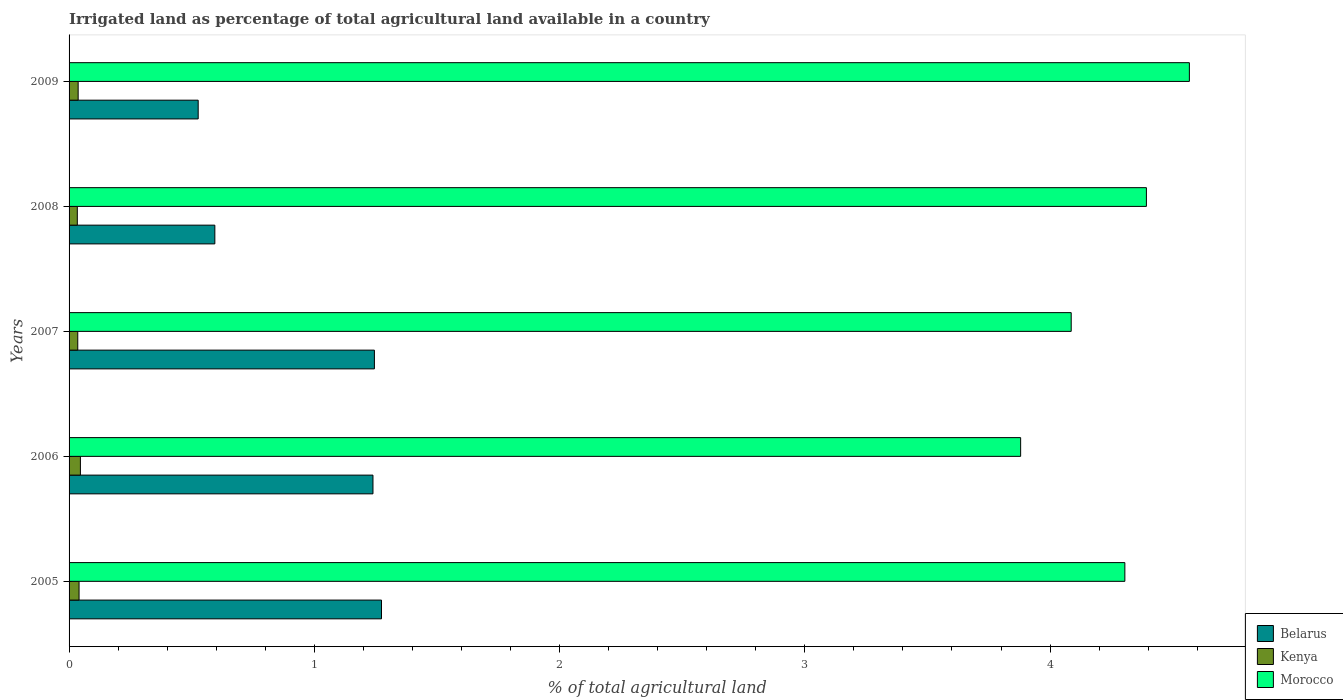How many different coloured bars are there?
Your answer should be compact. 3. How many groups of bars are there?
Make the answer very short. 5. Are the number of bars on each tick of the Y-axis equal?
Give a very brief answer. Yes. What is the percentage of irrigated land in Belarus in 2007?
Give a very brief answer. 1.24. Across all years, what is the maximum percentage of irrigated land in Kenya?
Your answer should be compact. 0.05. Across all years, what is the minimum percentage of irrigated land in Kenya?
Your answer should be very brief. 0.03. In which year was the percentage of irrigated land in Morocco maximum?
Make the answer very short. 2009. What is the total percentage of irrigated land in Kenya in the graph?
Offer a very short reply. 0.19. What is the difference between the percentage of irrigated land in Kenya in 2005 and that in 2006?
Provide a short and direct response. -0.01. What is the difference between the percentage of irrigated land in Belarus in 2005 and the percentage of irrigated land in Kenya in 2008?
Ensure brevity in your answer.  1.24. What is the average percentage of irrigated land in Kenya per year?
Provide a short and direct response. 0.04. In the year 2005, what is the difference between the percentage of irrigated land in Kenya and percentage of irrigated land in Morocco?
Offer a very short reply. -4.26. What is the ratio of the percentage of irrigated land in Belarus in 2007 to that in 2009?
Offer a very short reply. 2.36. Is the difference between the percentage of irrigated land in Kenya in 2005 and 2007 greater than the difference between the percentage of irrigated land in Morocco in 2005 and 2007?
Make the answer very short. No. What is the difference between the highest and the second highest percentage of irrigated land in Morocco?
Provide a succinct answer. 0.18. What is the difference between the highest and the lowest percentage of irrigated land in Belarus?
Give a very brief answer. 0.75. In how many years, is the percentage of irrigated land in Kenya greater than the average percentage of irrigated land in Kenya taken over all years?
Keep it short and to the point. 2. What does the 1st bar from the top in 2007 represents?
Ensure brevity in your answer.  Morocco. What does the 2nd bar from the bottom in 2008 represents?
Your response must be concise. Kenya. How many years are there in the graph?
Make the answer very short. 5. Does the graph contain any zero values?
Ensure brevity in your answer.  No. Does the graph contain grids?
Ensure brevity in your answer.  No. What is the title of the graph?
Offer a very short reply. Irrigated land as percentage of total agricultural land available in a country. Does "Mauritius" appear as one of the legend labels in the graph?
Offer a terse response. No. What is the label or title of the X-axis?
Give a very brief answer. % of total agricultural land. What is the % of total agricultural land of Belarus in 2005?
Provide a succinct answer. 1.27. What is the % of total agricultural land of Kenya in 2005?
Your answer should be very brief. 0.04. What is the % of total agricultural land in Morocco in 2005?
Keep it short and to the point. 4.3. What is the % of total agricultural land in Belarus in 2006?
Provide a succinct answer. 1.24. What is the % of total agricultural land in Kenya in 2006?
Offer a terse response. 0.05. What is the % of total agricultural land of Morocco in 2006?
Make the answer very short. 3.88. What is the % of total agricultural land in Belarus in 2007?
Provide a succinct answer. 1.24. What is the % of total agricultural land of Kenya in 2007?
Your answer should be compact. 0.04. What is the % of total agricultural land of Morocco in 2007?
Ensure brevity in your answer.  4.09. What is the % of total agricultural land of Belarus in 2008?
Provide a short and direct response. 0.59. What is the % of total agricultural land in Kenya in 2008?
Offer a very short reply. 0.03. What is the % of total agricultural land of Morocco in 2008?
Your response must be concise. 4.39. What is the % of total agricultural land of Belarus in 2009?
Make the answer very short. 0.53. What is the % of total agricultural land in Kenya in 2009?
Offer a very short reply. 0.04. What is the % of total agricultural land of Morocco in 2009?
Keep it short and to the point. 4.57. Across all years, what is the maximum % of total agricultural land in Belarus?
Your response must be concise. 1.27. Across all years, what is the maximum % of total agricultural land of Kenya?
Keep it short and to the point. 0.05. Across all years, what is the maximum % of total agricultural land in Morocco?
Keep it short and to the point. 4.57. Across all years, what is the minimum % of total agricultural land in Belarus?
Provide a succinct answer. 0.53. Across all years, what is the minimum % of total agricultural land in Kenya?
Your answer should be compact. 0.03. Across all years, what is the minimum % of total agricultural land in Morocco?
Provide a succinct answer. 3.88. What is the total % of total agricultural land of Belarus in the graph?
Ensure brevity in your answer.  4.88. What is the total % of total agricultural land in Kenya in the graph?
Provide a short and direct response. 0.19. What is the total % of total agricultural land in Morocco in the graph?
Your response must be concise. 21.23. What is the difference between the % of total agricultural land of Belarus in 2005 and that in 2006?
Your answer should be compact. 0.03. What is the difference between the % of total agricultural land of Kenya in 2005 and that in 2006?
Give a very brief answer. -0.01. What is the difference between the % of total agricultural land of Morocco in 2005 and that in 2006?
Your answer should be compact. 0.42. What is the difference between the % of total agricultural land of Belarus in 2005 and that in 2007?
Keep it short and to the point. 0.03. What is the difference between the % of total agricultural land of Kenya in 2005 and that in 2007?
Ensure brevity in your answer.  0.01. What is the difference between the % of total agricultural land of Morocco in 2005 and that in 2007?
Keep it short and to the point. 0.22. What is the difference between the % of total agricultural land of Belarus in 2005 and that in 2008?
Offer a very short reply. 0.68. What is the difference between the % of total agricultural land of Kenya in 2005 and that in 2008?
Your answer should be compact. 0.01. What is the difference between the % of total agricultural land of Morocco in 2005 and that in 2008?
Give a very brief answer. -0.09. What is the difference between the % of total agricultural land of Belarus in 2005 and that in 2009?
Ensure brevity in your answer.  0.75. What is the difference between the % of total agricultural land of Kenya in 2005 and that in 2009?
Give a very brief answer. 0. What is the difference between the % of total agricultural land in Morocco in 2005 and that in 2009?
Ensure brevity in your answer.  -0.26. What is the difference between the % of total agricultural land of Belarus in 2006 and that in 2007?
Give a very brief answer. -0.01. What is the difference between the % of total agricultural land in Kenya in 2006 and that in 2007?
Offer a very short reply. 0.01. What is the difference between the % of total agricultural land in Morocco in 2006 and that in 2007?
Your answer should be compact. -0.21. What is the difference between the % of total agricultural land in Belarus in 2006 and that in 2008?
Your answer should be very brief. 0.64. What is the difference between the % of total agricultural land of Kenya in 2006 and that in 2008?
Ensure brevity in your answer.  0.01. What is the difference between the % of total agricultural land in Morocco in 2006 and that in 2008?
Give a very brief answer. -0.51. What is the difference between the % of total agricultural land in Belarus in 2006 and that in 2009?
Keep it short and to the point. 0.71. What is the difference between the % of total agricultural land in Kenya in 2006 and that in 2009?
Your response must be concise. 0.01. What is the difference between the % of total agricultural land of Morocco in 2006 and that in 2009?
Provide a succinct answer. -0.69. What is the difference between the % of total agricultural land in Belarus in 2007 and that in 2008?
Make the answer very short. 0.65. What is the difference between the % of total agricultural land in Kenya in 2007 and that in 2008?
Keep it short and to the point. 0. What is the difference between the % of total agricultural land of Morocco in 2007 and that in 2008?
Give a very brief answer. -0.31. What is the difference between the % of total agricultural land in Belarus in 2007 and that in 2009?
Make the answer very short. 0.72. What is the difference between the % of total agricultural land of Kenya in 2007 and that in 2009?
Your answer should be compact. -0. What is the difference between the % of total agricultural land in Morocco in 2007 and that in 2009?
Provide a succinct answer. -0.48. What is the difference between the % of total agricultural land in Belarus in 2008 and that in 2009?
Ensure brevity in your answer.  0.07. What is the difference between the % of total agricultural land of Kenya in 2008 and that in 2009?
Keep it short and to the point. -0. What is the difference between the % of total agricultural land in Morocco in 2008 and that in 2009?
Your answer should be compact. -0.18. What is the difference between the % of total agricultural land in Belarus in 2005 and the % of total agricultural land in Kenya in 2006?
Offer a terse response. 1.23. What is the difference between the % of total agricultural land in Belarus in 2005 and the % of total agricultural land in Morocco in 2006?
Your response must be concise. -2.61. What is the difference between the % of total agricultural land of Kenya in 2005 and the % of total agricultural land of Morocco in 2006?
Offer a very short reply. -3.84. What is the difference between the % of total agricultural land in Belarus in 2005 and the % of total agricultural land in Kenya in 2007?
Provide a short and direct response. 1.24. What is the difference between the % of total agricultural land of Belarus in 2005 and the % of total agricultural land of Morocco in 2007?
Keep it short and to the point. -2.81. What is the difference between the % of total agricultural land of Kenya in 2005 and the % of total agricultural land of Morocco in 2007?
Your response must be concise. -4.05. What is the difference between the % of total agricultural land of Belarus in 2005 and the % of total agricultural land of Kenya in 2008?
Ensure brevity in your answer.  1.24. What is the difference between the % of total agricultural land of Belarus in 2005 and the % of total agricultural land of Morocco in 2008?
Provide a short and direct response. -3.12. What is the difference between the % of total agricultural land in Kenya in 2005 and the % of total agricultural land in Morocco in 2008?
Ensure brevity in your answer.  -4.35. What is the difference between the % of total agricultural land in Belarus in 2005 and the % of total agricultural land in Kenya in 2009?
Provide a short and direct response. 1.24. What is the difference between the % of total agricultural land in Belarus in 2005 and the % of total agricultural land in Morocco in 2009?
Your answer should be very brief. -3.29. What is the difference between the % of total agricultural land in Kenya in 2005 and the % of total agricultural land in Morocco in 2009?
Provide a succinct answer. -4.53. What is the difference between the % of total agricultural land in Belarus in 2006 and the % of total agricultural land in Kenya in 2007?
Your answer should be compact. 1.2. What is the difference between the % of total agricultural land of Belarus in 2006 and the % of total agricultural land of Morocco in 2007?
Your answer should be compact. -2.85. What is the difference between the % of total agricultural land in Kenya in 2006 and the % of total agricultural land in Morocco in 2007?
Make the answer very short. -4.04. What is the difference between the % of total agricultural land of Belarus in 2006 and the % of total agricultural land of Kenya in 2008?
Your answer should be compact. 1.21. What is the difference between the % of total agricultural land in Belarus in 2006 and the % of total agricultural land in Morocco in 2008?
Offer a very short reply. -3.15. What is the difference between the % of total agricultural land in Kenya in 2006 and the % of total agricultural land in Morocco in 2008?
Your answer should be very brief. -4.35. What is the difference between the % of total agricultural land in Belarus in 2006 and the % of total agricultural land in Kenya in 2009?
Your answer should be very brief. 1.2. What is the difference between the % of total agricultural land of Belarus in 2006 and the % of total agricultural land of Morocco in 2009?
Ensure brevity in your answer.  -3.33. What is the difference between the % of total agricultural land of Kenya in 2006 and the % of total agricultural land of Morocco in 2009?
Provide a succinct answer. -4.52. What is the difference between the % of total agricultural land in Belarus in 2007 and the % of total agricultural land in Kenya in 2008?
Your answer should be very brief. 1.21. What is the difference between the % of total agricultural land in Belarus in 2007 and the % of total agricultural land in Morocco in 2008?
Give a very brief answer. -3.15. What is the difference between the % of total agricultural land of Kenya in 2007 and the % of total agricultural land of Morocco in 2008?
Your response must be concise. -4.36. What is the difference between the % of total agricultural land of Belarus in 2007 and the % of total agricultural land of Kenya in 2009?
Provide a succinct answer. 1.21. What is the difference between the % of total agricultural land of Belarus in 2007 and the % of total agricultural land of Morocco in 2009?
Provide a succinct answer. -3.32. What is the difference between the % of total agricultural land of Kenya in 2007 and the % of total agricultural land of Morocco in 2009?
Provide a short and direct response. -4.53. What is the difference between the % of total agricultural land in Belarus in 2008 and the % of total agricultural land in Kenya in 2009?
Ensure brevity in your answer.  0.56. What is the difference between the % of total agricultural land of Belarus in 2008 and the % of total agricultural land of Morocco in 2009?
Keep it short and to the point. -3.97. What is the difference between the % of total agricultural land of Kenya in 2008 and the % of total agricultural land of Morocco in 2009?
Ensure brevity in your answer.  -4.53. What is the average % of total agricultural land of Belarus per year?
Give a very brief answer. 0.98. What is the average % of total agricultural land in Kenya per year?
Keep it short and to the point. 0.04. What is the average % of total agricultural land in Morocco per year?
Offer a terse response. 4.25. In the year 2005, what is the difference between the % of total agricultural land in Belarus and % of total agricultural land in Kenya?
Provide a short and direct response. 1.23. In the year 2005, what is the difference between the % of total agricultural land in Belarus and % of total agricultural land in Morocco?
Keep it short and to the point. -3.03. In the year 2005, what is the difference between the % of total agricultural land in Kenya and % of total agricultural land in Morocco?
Your answer should be very brief. -4.26. In the year 2006, what is the difference between the % of total agricultural land in Belarus and % of total agricultural land in Kenya?
Provide a succinct answer. 1.19. In the year 2006, what is the difference between the % of total agricultural land of Belarus and % of total agricultural land of Morocco?
Your response must be concise. -2.64. In the year 2006, what is the difference between the % of total agricultural land of Kenya and % of total agricultural land of Morocco?
Provide a succinct answer. -3.83. In the year 2007, what is the difference between the % of total agricultural land of Belarus and % of total agricultural land of Kenya?
Offer a terse response. 1.21. In the year 2007, what is the difference between the % of total agricultural land in Belarus and % of total agricultural land in Morocco?
Give a very brief answer. -2.84. In the year 2007, what is the difference between the % of total agricultural land in Kenya and % of total agricultural land in Morocco?
Make the answer very short. -4.05. In the year 2008, what is the difference between the % of total agricultural land in Belarus and % of total agricultural land in Kenya?
Give a very brief answer. 0.56. In the year 2008, what is the difference between the % of total agricultural land of Belarus and % of total agricultural land of Morocco?
Offer a very short reply. -3.8. In the year 2008, what is the difference between the % of total agricultural land of Kenya and % of total agricultural land of Morocco?
Offer a terse response. -4.36. In the year 2009, what is the difference between the % of total agricultural land of Belarus and % of total agricultural land of Kenya?
Make the answer very short. 0.49. In the year 2009, what is the difference between the % of total agricultural land of Belarus and % of total agricultural land of Morocco?
Provide a short and direct response. -4.04. In the year 2009, what is the difference between the % of total agricultural land in Kenya and % of total agricultural land in Morocco?
Your answer should be compact. -4.53. What is the ratio of the % of total agricultural land of Belarus in 2005 to that in 2006?
Your answer should be compact. 1.03. What is the ratio of the % of total agricultural land in Kenya in 2005 to that in 2006?
Provide a succinct answer. 0.88. What is the ratio of the % of total agricultural land of Morocco in 2005 to that in 2006?
Ensure brevity in your answer.  1.11. What is the ratio of the % of total agricultural land of Belarus in 2005 to that in 2007?
Make the answer very short. 1.02. What is the ratio of the % of total agricultural land in Kenya in 2005 to that in 2007?
Offer a terse response. 1.15. What is the ratio of the % of total agricultural land in Morocco in 2005 to that in 2007?
Your answer should be compact. 1.05. What is the ratio of the % of total agricultural land of Belarus in 2005 to that in 2008?
Offer a terse response. 2.14. What is the ratio of the % of total agricultural land of Kenya in 2005 to that in 2008?
Provide a short and direct response. 1.21. What is the ratio of the % of total agricultural land of Morocco in 2005 to that in 2008?
Offer a terse response. 0.98. What is the ratio of the % of total agricultural land of Belarus in 2005 to that in 2009?
Your answer should be very brief. 2.42. What is the ratio of the % of total agricultural land of Kenya in 2005 to that in 2009?
Your response must be concise. 1.1. What is the ratio of the % of total agricultural land of Morocco in 2005 to that in 2009?
Your answer should be compact. 0.94. What is the ratio of the % of total agricultural land in Belarus in 2006 to that in 2007?
Make the answer very short. 1. What is the ratio of the % of total agricultural land of Kenya in 2006 to that in 2007?
Ensure brevity in your answer.  1.3. What is the ratio of the % of total agricultural land of Morocco in 2006 to that in 2007?
Your response must be concise. 0.95. What is the ratio of the % of total agricultural land of Belarus in 2006 to that in 2008?
Ensure brevity in your answer.  2.08. What is the ratio of the % of total agricultural land in Kenya in 2006 to that in 2008?
Provide a succinct answer. 1.38. What is the ratio of the % of total agricultural land of Morocco in 2006 to that in 2008?
Offer a very short reply. 0.88. What is the ratio of the % of total agricultural land of Belarus in 2006 to that in 2009?
Your response must be concise. 2.35. What is the ratio of the % of total agricultural land of Kenya in 2006 to that in 2009?
Your answer should be very brief. 1.25. What is the ratio of the % of total agricultural land in Morocco in 2006 to that in 2009?
Give a very brief answer. 0.85. What is the ratio of the % of total agricultural land in Belarus in 2007 to that in 2008?
Ensure brevity in your answer.  2.09. What is the ratio of the % of total agricultural land in Kenya in 2007 to that in 2008?
Keep it short and to the point. 1.06. What is the ratio of the % of total agricultural land in Morocco in 2007 to that in 2008?
Offer a terse response. 0.93. What is the ratio of the % of total agricultural land in Belarus in 2007 to that in 2009?
Your response must be concise. 2.36. What is the ratio of the % of total agricultural land in Kenya in 2007 to that in 2009?
Keep it short and to the point. 0.96. What is the ratio of the % of total agricultural land of Morocco in 2007 to that in 2009?
Your answer should be very brief. 0.89. What is the ratio of the % of total agricultural land in Belarus in 2008 to that in 2009?
Make the answer very short. 1.13. What is the ratio of the % of total agricultural land in Kenya in 2008 to that in 2009?
Give a very brief answer. 0.91. What is the ratio of the % of total agricultural land in Morocco in 2008 to that in 2009?
Your response must be concise. 0.96. What is the difference between the highest and the second highest % of total agricultural land of Belarus?
Make the answer very short. 0.03. What is the difference between the highest and the second highest % of total agricultural land in Kenya?
Provide a short and direct response. 0.01. What is the difference between the highest and the second highest % of total agricultural land in Morocco?
Your answer should be very brief. 0.18. What is the difference between the highest and the lowest % of total agricultural land of Belarus?
Your answer should be very brief. 0.75. What is the difference between the highest and the lowest % of total agricultural land in Kenya?
Provide a short and direct response. 0.01. What is the difference between the highest and the lowest % of total agricultural land in Morocco?
Offer a very short reply. 0.69. 